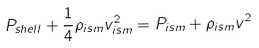<formula> <loc_0><loc_0><loc_500><loc_500>P _ { s h e l l } + \frac { 1 } { 4 } \rho _ { i s m } v _ { i s m } ^ { 2 } = P _ { i s m } + \rho _ { i s m } v ^ { 2 }</formula> 